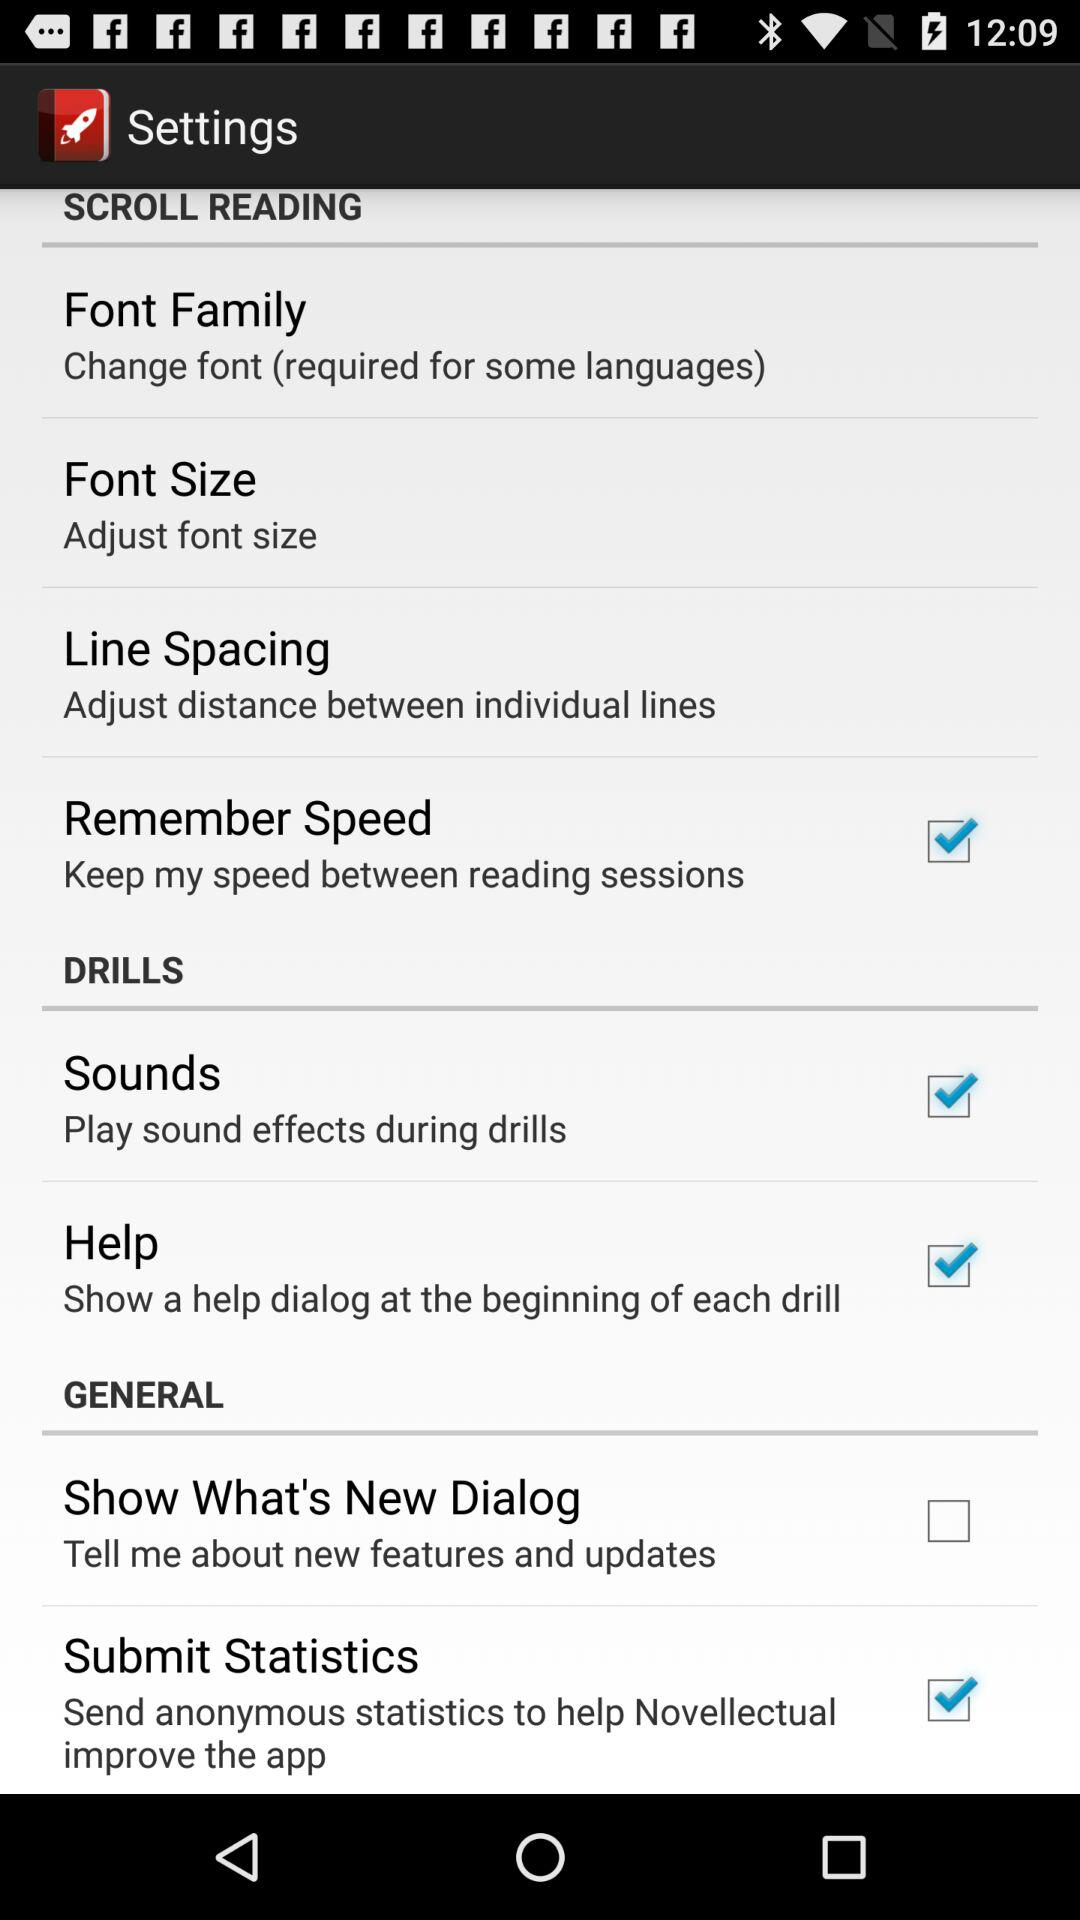What is the status of "Remember Speed"? The status is "on". 